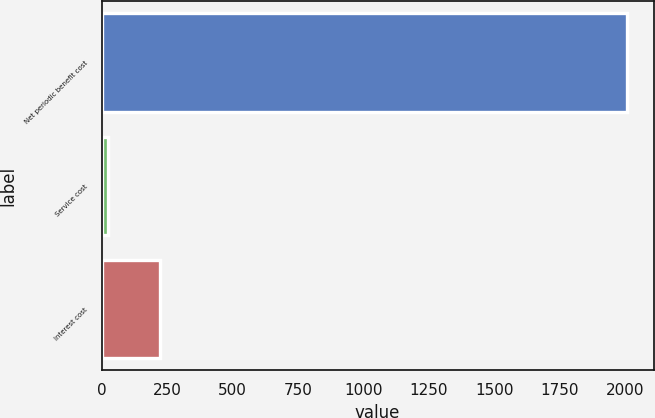<chart> <loc_0><loc_0><loc_500><loc_500><bar_chart><fcel>Net periodic benefit cost<fcel>Service cost<fcel>Interest cost<nl><fcel>2009<fcel>26<fcel>224.3<nl></chart> 